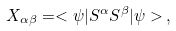Convert formula to latex. <formula><loc_0><loc_0><loc_500><loc_500>X _ { \alpha \beta } = < \psi | S ^ { \alpha } S ^ { \beta } | \psi > \, ,</formula> 